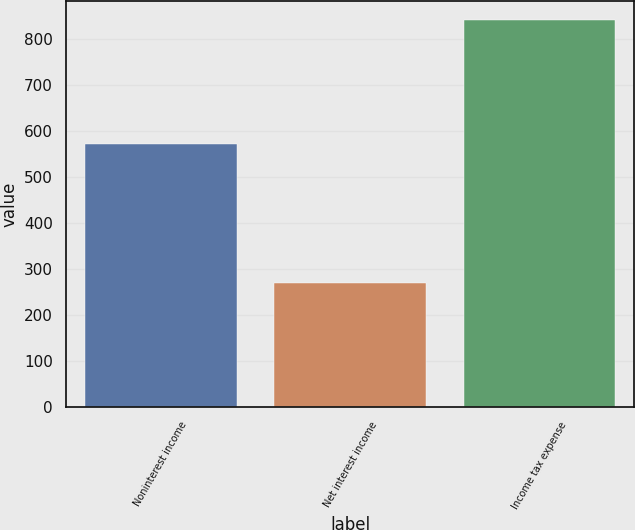Convert chart. <chart><loc_0><loc_0><loc_500><loc_500><bar_chart><fcel>Noninterest income<fcel>Net interest income<fcel>Income tax expense<nl><fcel>571<fcel>269<fcel>840<nl></chart> 